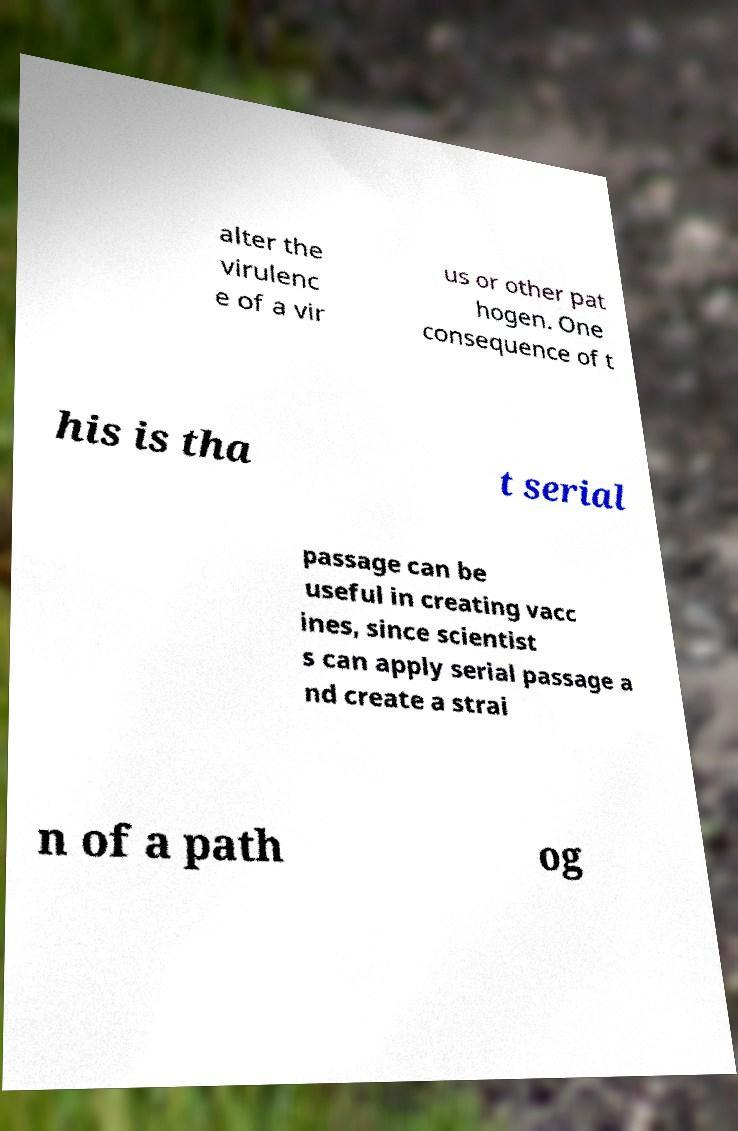Could you assist in decoding the text presented in this image and type it out clearly? alter the virulenc e of a vir us or other pat hogen. One consequence of t his is tha t serial passage can be useful in creating vacc ines, since scientist s can apply serial passage a nd create a strai n of a path og 